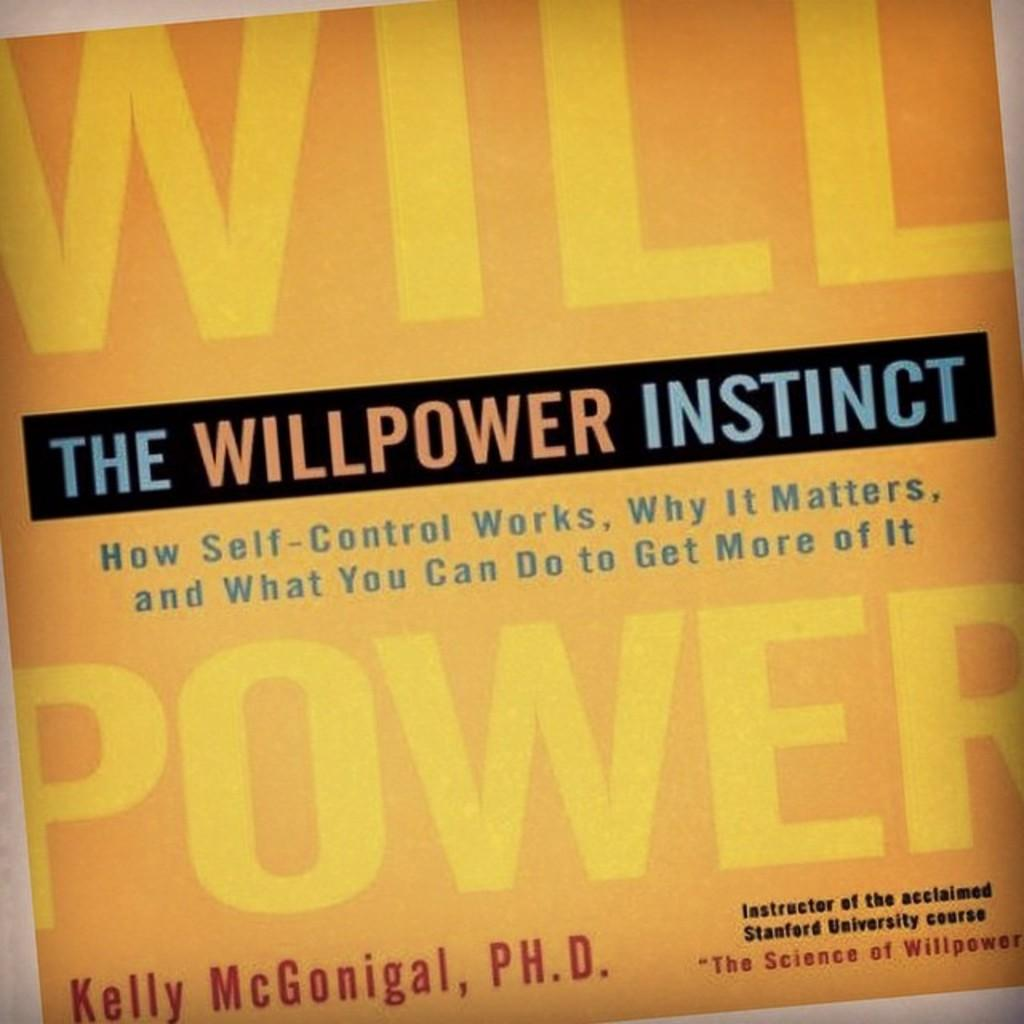<image>
Relay a brief, clear account of the picture shown. The yellow cover of the book "The Willpower Instinct". 